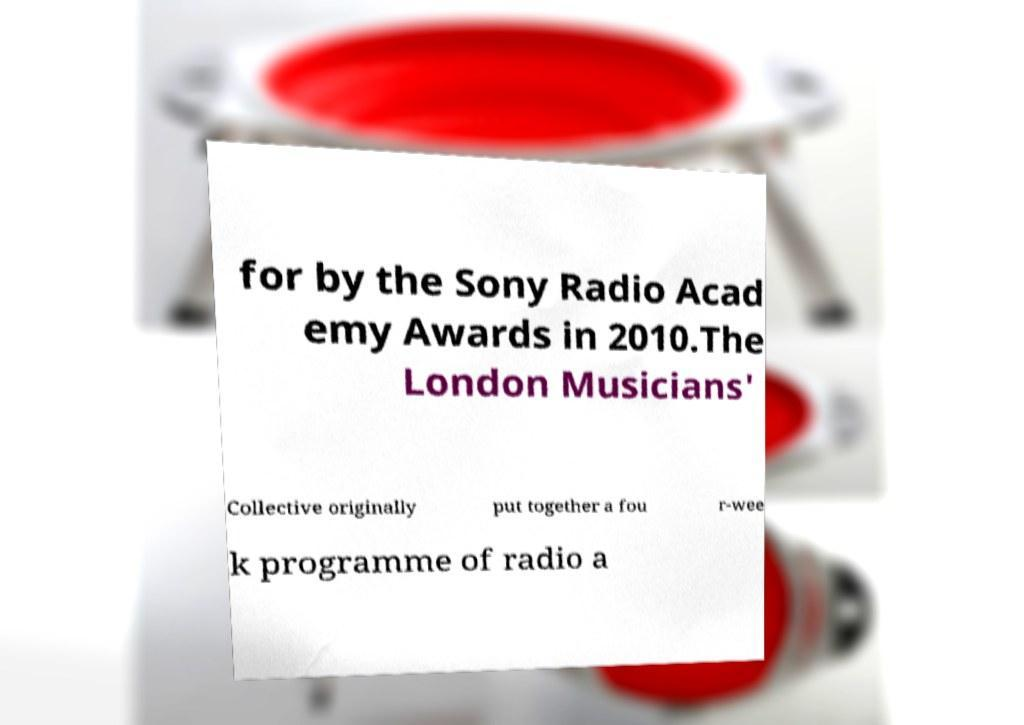Can you accurately transcribe the text from the provided image for me? for by the Sony Radio Acad emy Awards in 2010.The London Musicians' Collective originally put together a fou r-wee k programme of radio a 